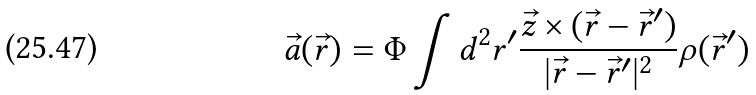Convert formula to latex. <formula><loc_0><loc_0><loc_500><loc_500>\vec { a } ( \vec { r } ) = \Phi \int { d ^ { 2 } r ^ { \prime } \frac { \vec { z } \times ( \vec { r } - \vec { r } ^ { \prime } ) } { | \vec { r } - \vec { r } ^ { \prime } | ^ { 2 } } \rho ( \vec { r } ^ { \prime } ) }</formula> 